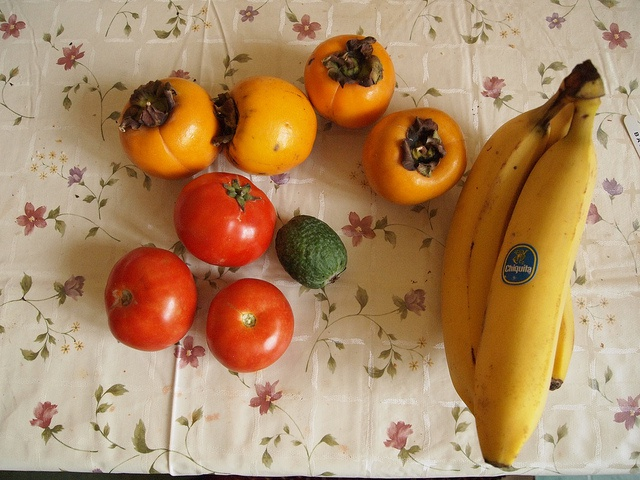Describe the objects in this image and their specific colors. I can see a banana in darkgray, brown, maroon, orange, and khaki tones in this image. 